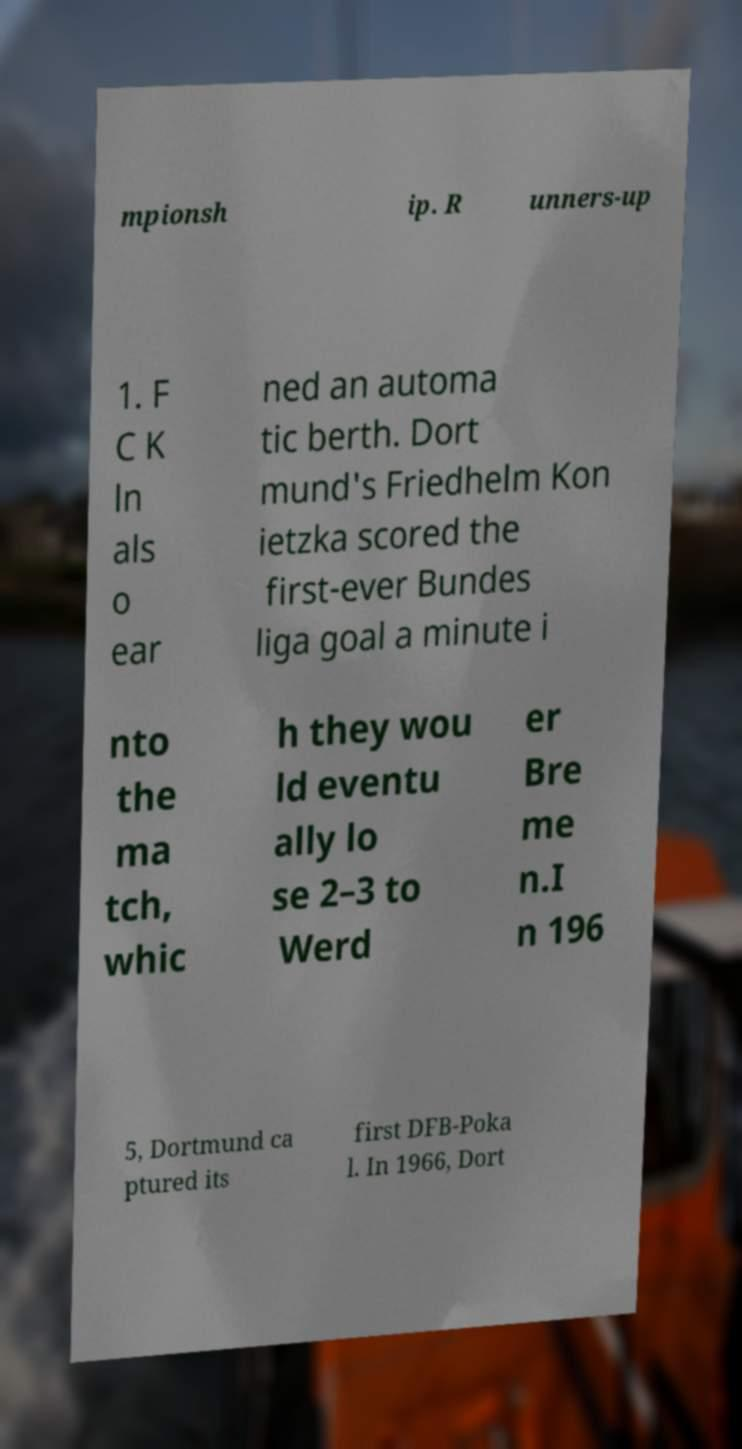Can you read and provide the text displayed in the image?This photo seems to have some interesting text. Can you extract and type it out for me? mpionsh ip. R unners-up 1. F C K ln als o ear ned an automa tic berth. Dort mund's Friedhelm Kon ietzka scored the first-ever Bundes liga goal a minute i nto the ma tch, whic h they wou ld eventu ally lo se 2–3 to Werd er Bre me n.I n 196 5, Dortmund ca ptured its first DFB-Poka l. In 1966, Dort 